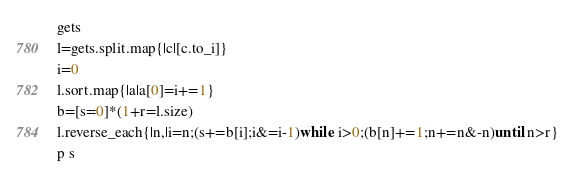Convert code to text. <code><loc_0><loc_0><loc_500><loc_500><_Ruby_>gets
l=gets.split.map{|c|[c.to_i]}
i=0
l.sort.map{|a|a[0]=i+=1}
b=[s=0]*(1+r=l.size)
l.reverse_each{|n,|i=n;(s+=b[i];i&=i-1)while i>0;(b[n]+=1;n+=n&-n)until n>r}
p s</code> 